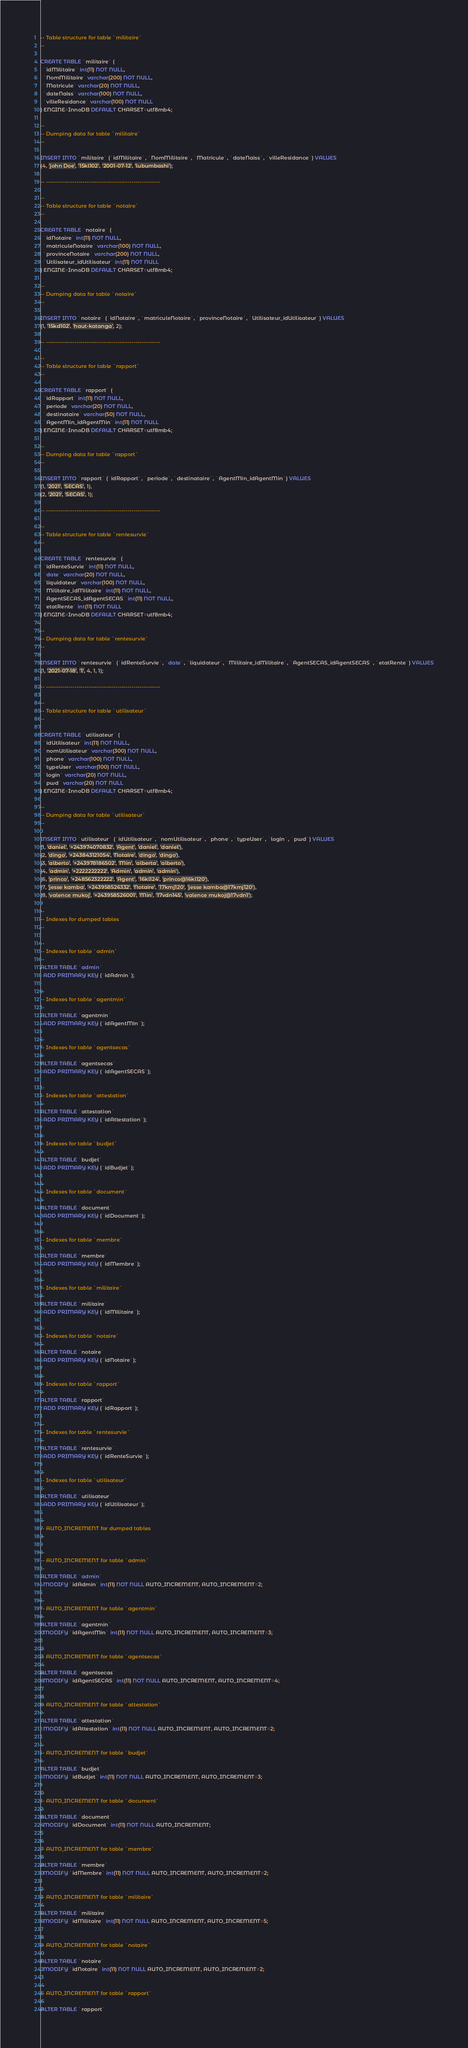<code> <loc_0><loc_0><loc_500><loc_500><_SQL_>-- Table structure for table `militaire`
--

CREATE TABLE `militaire` (
  `idMilitaire` int(11) NOT NULL,
  `NomMilitaire` varchar(200) NOT NULL,
  `Matricule` varchar(20) NOT NULL,
  `dateNaiss` varchar(100) NOT NULL,
  `villeResidance` varchar(100) NOT NULL
) ENGINE=InnoDB DEFAULT CHARSET=utf8mb4;

--
-- Dumping data for table `militaire`
--

INSERT INTO `militaire` (`idMilitaire`, `NomMilitaire`, `Matricule`, `dateNaiss`, `villeResidance`) VALUES
(4, 'john Doe', '15kl102', '2001-07-12', 'lubumbashi');

-- --------------------------------------------------------

--
-- Table structure for table `notaire`
--

CREATE TABLE `notaire` (
  `idNotaire` int(11) NOT NULL,
  `matriculeNotaire` varchar(100) NOT NULL,
  `provinceNotaire` varchar(200) NOT NULL,
  `Utilisateur_idUtilisateur` int(11) NOT NULL
) ENGINE=InnoDB DEFAULT CHARSET=utf8mb4;

--
-- Dumping data for table `notaire`
--

INSERT INTO `notaire` (`idNotaire`, `matriculeNotaire`, `provinceNotaire`, `Utilisateur_idUtilisateur`) VALUES
(1, '15kd102', 'haut-katanga', 2);

-- --------------------------------------------------------

--
-- Table structure for table `rapport`
--

CREATE TABLE `rapport` (
  `idRapport` int(11) NOT NULL,
  `periode` varchar(20) NOT NULL,
  `destinataire` varchar(50) NOT NULL,
  `AgentMin_idAgentMin` int(11) NOT NULL
) ENGINE=InnoDB DEFAULT CHARSET=utf8mb4;

--
-- Dumping data for table `rapport`
--

INSERT INTO `rapport` (`idRapport`, `periode`, `destinataire`, `AgentMin_idAgentMin`) VALUES
(1, '2021', 'SECAS', 1),
(2, '2021', 'SECAS', 1);

-- --------------------------------------------------------

--
-- Table structure for table `rentesurvie`
--

CREATE TABLE `rentesurvie` (
  `idRenteSurvie` int(11) NOT NULL,
  `date` varchar(20) NOT NULL,
  `liquidateur` varchar(100) NOT NULL,
  `Militaire_idMilitaire` int(11) NOT NULL,
  `AgentSECAS_idAgentSECAS` int(11) NOT NULL,
  `etatRente` int(11) NOT NULL
) ENGINE=InnoDB DEFAULT CHARSET=utf8mb4;

--
-- Dumping data for table `rentesurvie`
--

INSERT INTO `rentesurvie` (`idRenteSurvie`, `date`, `liquidateur`, `Militaire_idMilitaire`, `AgentSECAS_idAgentSECAS`, `etatRente`) VALUES
(1, '2021-07-18', '1', 4, 1, 1);

-- --------------------------------------------------------

--
-- Table structure for table `utilisateur`
--

CREATE TABLE `utilisateur` (
  `idUtilisateur` int(11) NOT NULL,
  `nomUtilisateur` varchar(300) NOT NULL,
  `phone` varchar(100) NOT NULL,
  `typeUser` varchar(100) NOT NULL,
  `login` varchar(20) NOT NULL,
  `pwd` varchar(20) NOT NULL
) ENGINE=InnoDB DEFAULT CHARSET=utf8mb4;

--
-- Dumping data for table `utilisateur`
--

INSERT INTO `utilisateur` (`idUtilisateur`, `nomUtilisateur`, `phone`, `typeUser`, `login`, `pwd`) VALUES
(1, 'daniel', '+243974070832', 'Agent', 'daniel', 'daniel'),
(2, 'dingo', '+243843121054', 'Notaire', 'dingo', 'dingo'),
(3, 'alberto', '+243978186502', 'Min', 'alberta', 'alberto'),
(4, 'admin', '+2222222222', 'Admin', 'admin', 'admin'),
(6, 'princo', '+248562322222', 'Agent', '16kl124', 'princo@16kl120'),
(7, 'jesse kamba', '+243958526332', 'Notaire', '17kmj120', 'jesse kamba@17kmj120'),
(8, 'valence mukoj', '+243958526001', 'Min', '17vdn145', 'valence mukoj@17vdn1');

--
-- Indexes for dumped tables
--

--
-- Indexes for table `admin`
--
ALTER TABLE `admin`
  ADD PRIMARY KEY (`idAdmin`);

--
-- Indexes for table `agentmin`
--
ALTER TABLE `agentmin`
  ADD PRIMARY KEY (`idAgentMin`);

--
-- Indexes for table `agentsecas`
--
ALTER TABLE `agentsecas`
  ADD PRIMARY KEY (`idAgentSECAS`);

--
-- Indexes for table `attestation`
--
ALTER TABLE `attestation`
  ADD PRIMARY KEY (`idAttestation`);

--
-- Indexes for table `budjet`
--
ALTER TABLE `budjet`
  ADD PRIMARY KEY (`idBudjet`);

--
-- Indexes for table `document`
--
ALTER TABLE `document`
  ADD PRIMARY KEY (`idDocument`);

--
-- Indexes for table `membre`
--
ALTER TABLE `membre`
  ADD PRIMARY KEY (`idMembre`);

--
-- Indexes for table `militaire`
--
ALTER TABLE `militaire`
  ADD PRIMARY KEY (`idMilitaire`);

--
-- Indexes for table `notaire`
--
ALTER TABLE `notaire`
  ADD PRIMARY KEY (`idNotaire`);

--
-- Indexes for table `rapport`
--
ALTER TABLE `rapport`
  ADD PRIMARY KEY (`idRapport`);

--
-- Indexes for table `rentesurvie`
--
ALTER TABLE `rentesurvie`
  ADD PRIMARY KEY (`idRenteSurvie`);

--
-- Indexes for table `utilisateur`
--
ALTER TABLE `utilisateur`
  ADD PRIMARY KEY (`idUtilisateur`);

--
-- AUTO_INCREMENT for dumped tables
--

--
-- AUTO_INCREMENT for table `admin`
--
ALTER TABLE `admin`
  MODIFY `idAdmin` int(11) NOT NULL AUTO_INCREMENT, AUTO_INCREMENT=2;

--
-- AUTO_INCREMENT for table `agentmin`
--
ALTER TABLE `agentmin`
  MODIFY `idAgentMin` int(11) NOT NULL AUTO_INCREMENT, AUTO_INCREMENT=3;

--
-- AUTO_INCREMENT for table `agentsecas`
--
ALTER TABLE `agentsecas`
  MODIFY `idAgentSECAS` int(11) NOT NULL AUTO_INCREMENT, AUTO_INCREMENT=4;

--
-- AUTO_INCREMENT for table `attestation`
--
ALTER TABLE `attestation`
  MODIFY `idAttestation` int(11) NOT NULL AUTO_INCREMENT, AUTO_INCREMENT=2;

--
-- AUTO_INCREMENT for table `budjet`
--
ALTER TABLE `budjet`
  MODIFY `idBudjet` int(11) NOT NULL AUTO_INCREMENT, AUTO_INCREMENT=3;

--
-- AUTO_INCREMENT for table `document`
--
ALTER TABLE `document`
  MODIFY `idDocument` int(11) NOT NULL AUTO_INCREMENT;

--
-- AUTO_INCREMENT for table `membre`
--
ALTER TABLE `membre`
  MODIFY `idMembre` int(11) NOT NULL AUTO_INCREMENT, AUTO_INCREMENT=2;

--
-- AUTO_INCREMENT for table `militaire`
--
ALTER TABLE `militaire`
  MODIFY `idMilitaire` int(11) NOT NULL AUTO_INCREMENT, AUTO_INCREMENT=5;

--
-- AUTO_INCREMENT for table `notaire`
--
ALTER TABLE `notaire`
  MODIFY `idNotaire` int(11) NOT NULL AUTO_INCREMENT, AUTO_INCREMENT=2;

--
-- AUTO_INCREMENT for table `rapport`
--
ALTER TABLE `rapport`</code> 